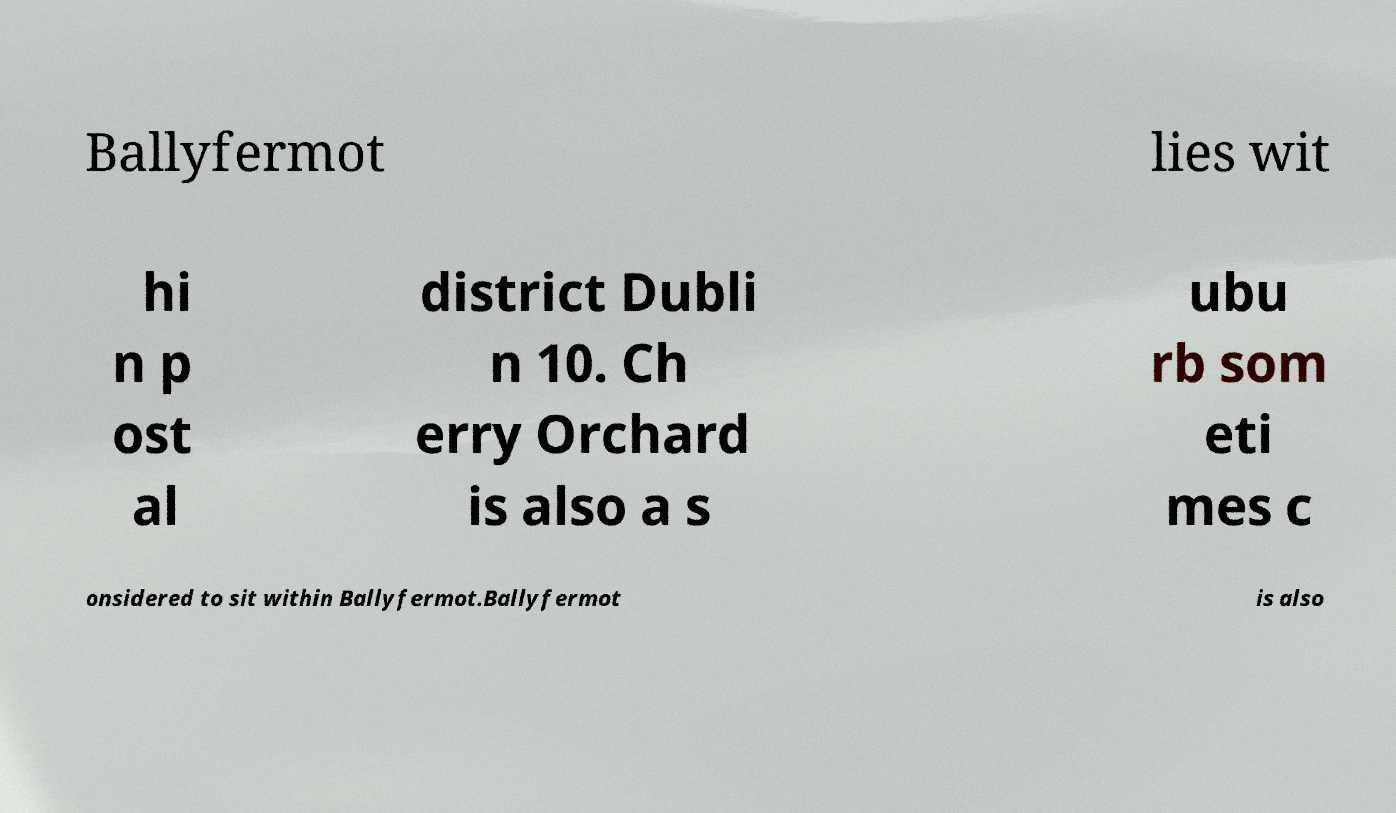Please identify and transcribe the text found in this image. Ballyfermot lies wit hi n p ost al district Dubli n 10. Ch erry Orchard is also a s ubu rb som eti mes c onsidered to sit within Ballyfermot.Ballyfermot is also 